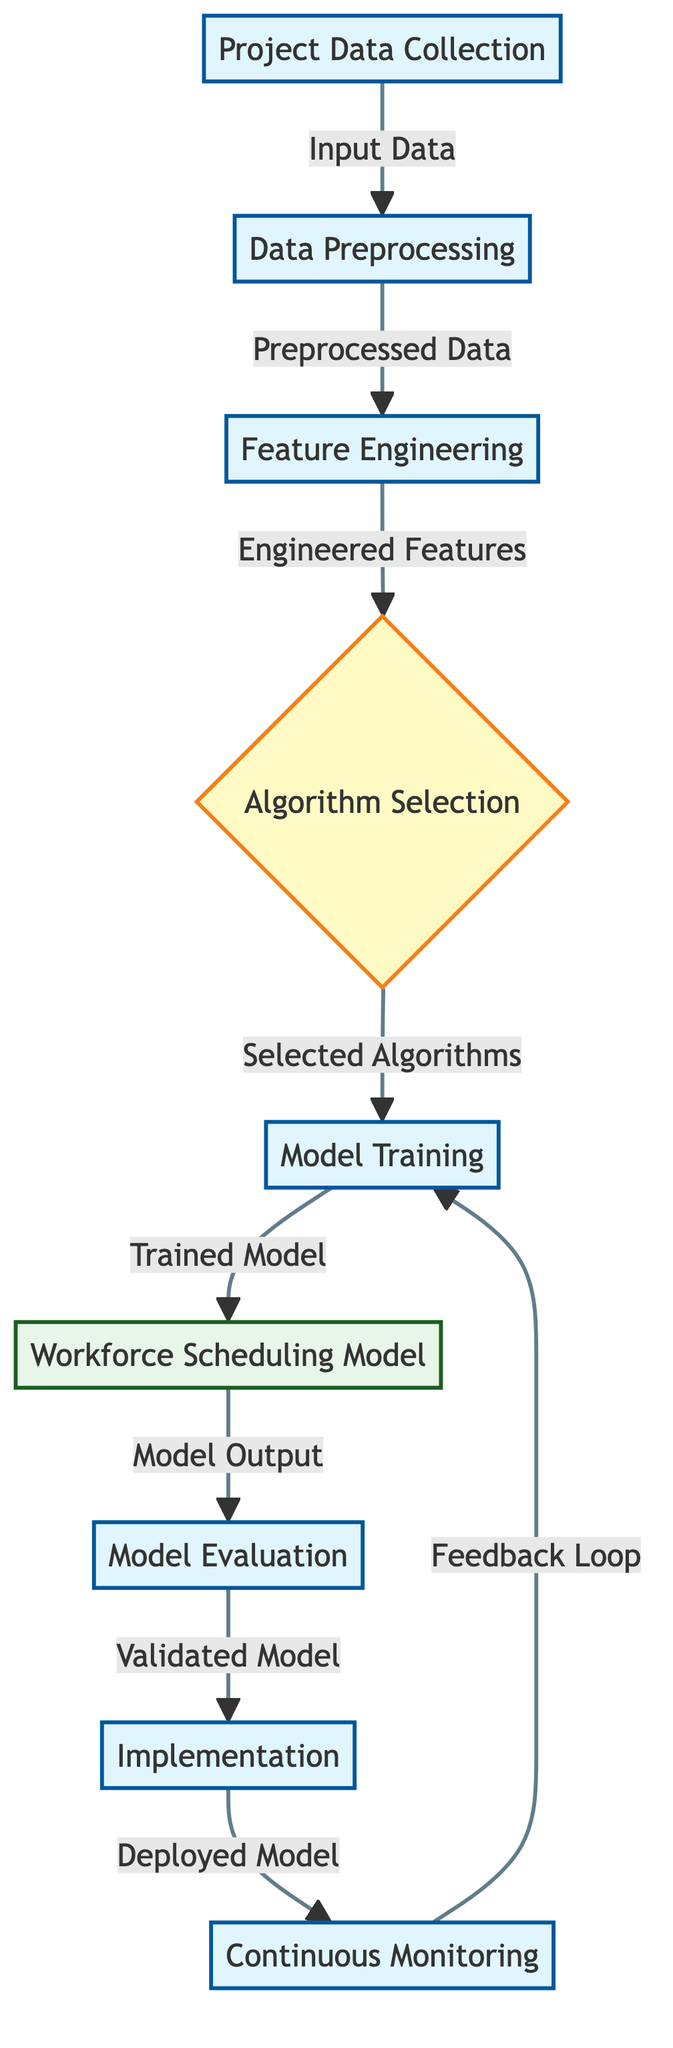What is the first step in the process? The diagram indicates that the first step is "Project Data Collection", which is the first node in the flowchart.
Answer: Project Data Collection How many total steps are shown in the diagram? Each distinct node represents a step in the diagram. There are a total of nine nodes, including both processes and decisions.
Answer: Nine What connects "Data Preprocessing" and "Feature Engineering"? The arrow indicates a directional flow from "Data Preprocessing", showing that its output is fed into "Feature Engineering".
Answer: Preprocessed Data Which node represents the final output of the machine learning process? The last node in the diagram, "Continuous Monitoring", represents the final output as it follows the deployment of the model.
Answer: Continuous Monitoring What is the main output of the "Model Training" step? The output from the "Model Training" step is indicated as "Trained Model", which leads to the next step in the process.
Answer: Trained Model What process follows the "Model Evaluation"? According to the flow of the diagram, the process that follows "Model Evaluation" is "Implementation", signifying model deployment.
Answer: Implementation Which two processes form a feedback loop in the diagram? The feedback loop is formed between "Continuous Monitoring" and "Model Training", creating an iterative process for improving the model based on performance feedback.
Answer: Continuous Monitoring and Model Training What decision is made in the diagram? The decision node in the diagram is "Algorithm Selection", where a choice is made about which algorithms to use for model training.
Answer: Algorithm Selection What happens after "Workforce Scheduling Model"? The output from "Workforce Scheduling Model" leads to "Model Evaluation", which is the subsequent process to assess the model's performance.
Answer: Model Evaluation 